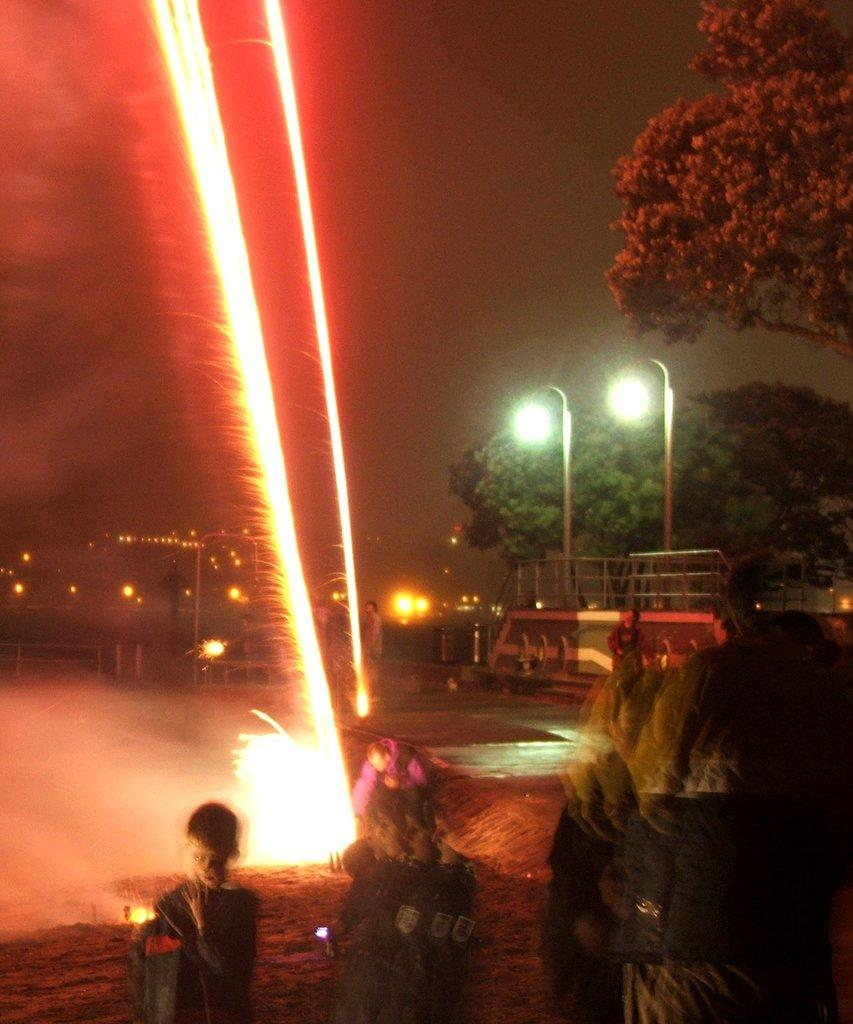How many people are in the image? There are persons standing in the image. What can be seen in the background of the image? There are lights and trees visible in the background of the image. What is the color of the sky in the image? The sky appears to be white in color. What type of property can be seen being drawn with chalk in the image? There is no property or chalk present in the image. How many passengers are visible in the image? There is no reference to passengers in the image; it features persons standing. 